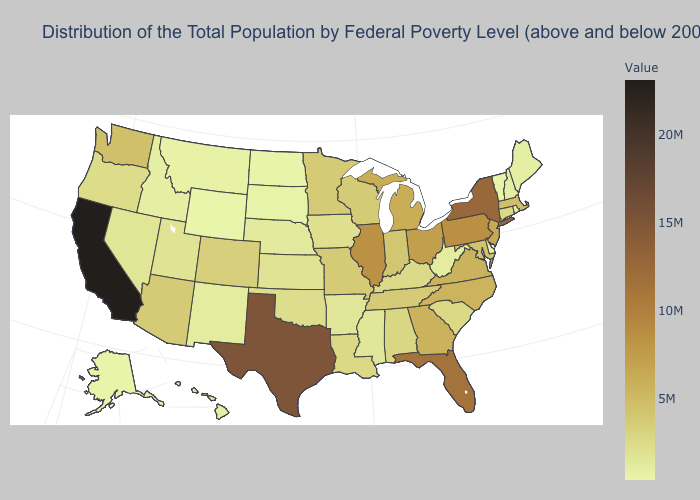Does Wyoming have a higher value than Arizona?
Write a very short answer. No. Among the states that border Nevada , which have the highest value?
Short answer required. California. Which states have the lowest value in the USA?
Answer briefly. Wyoming. Which states hav the highest value in the MidWest?
Quick response, please. Illinois. Does North Carolina have the lowest value in the South?
Be succinct. No. Does Illinois have the lowest value in the USA?
Give a very brief answer. No. Among the states that border Missouri , does Illinois have the highest value?
Be succinct. Yes. Among the states that border Texas , does Louisiana have the highest value?
Be succinct. Yes. 